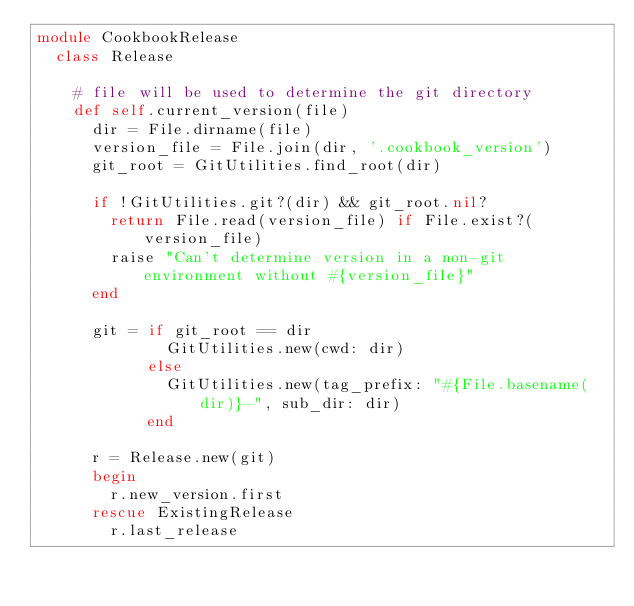<code> <loc_0><loc_0><loc_500><loc_500><_Ruby_>module CookbookRelease
  class Release

    # file will be used to determine the git directory
    def self.current_version(file)
      dir = File.dirname(file)
      version_file = File.join(dir, '.cookbook_version')
      git_root = GitUtilities.find_root(dir)

      if !GitUtilities.git?(dir) && git_root.nil?
        return File.read(version_file) if File.exist?(version_file)
        raise "Can't determine version in a non-git environment without #{version_file}"
      end

      git = if git_root == dir
              GitUtilities.new(cwd: dir)
            else
              GitUtilities.new(tag_prefix: "#{File.basename(dir)}-", sub_dir: dir)
            end

      r = Release.new(git)
      begin
        r.new_version.first
      rescue ExistingRelease
        r.last_release</code> 